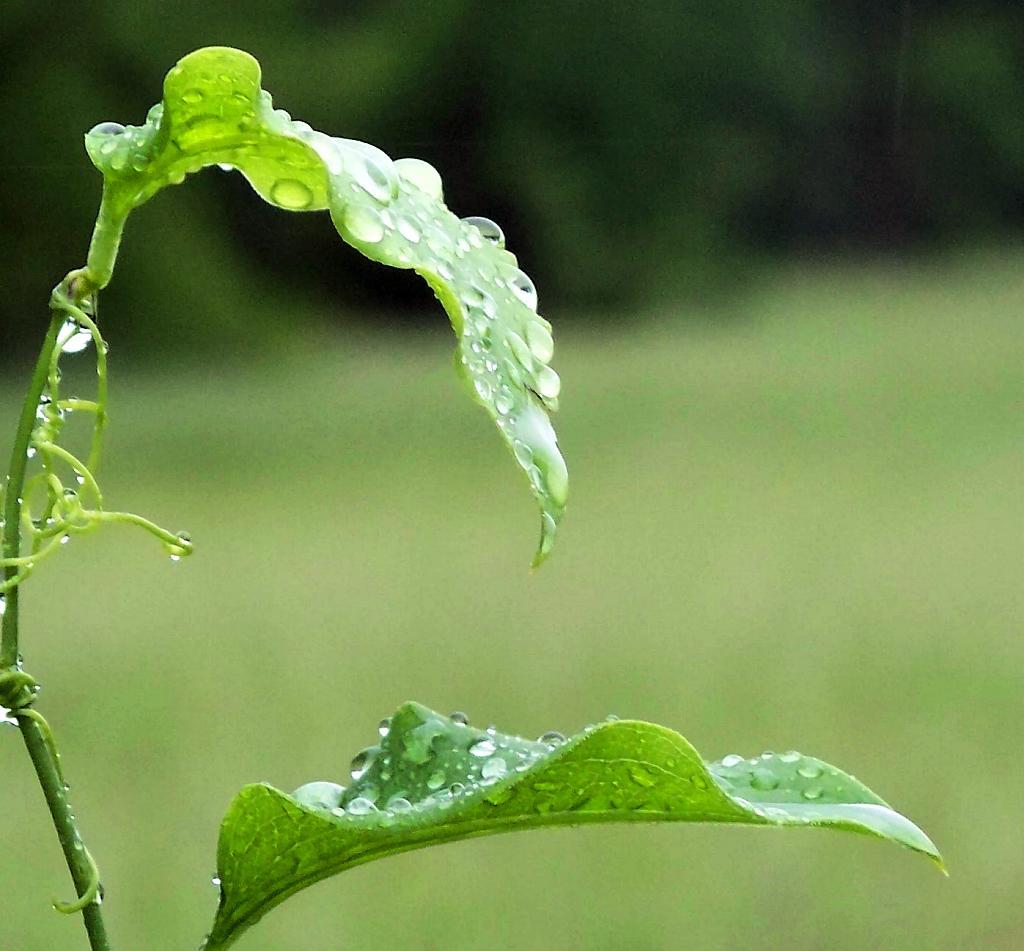Please provide a concise description of this image. In the picture we can see a plant with two leaves and on it we can see water droplets and behind it, we can see greenery which is not clearly visible. 